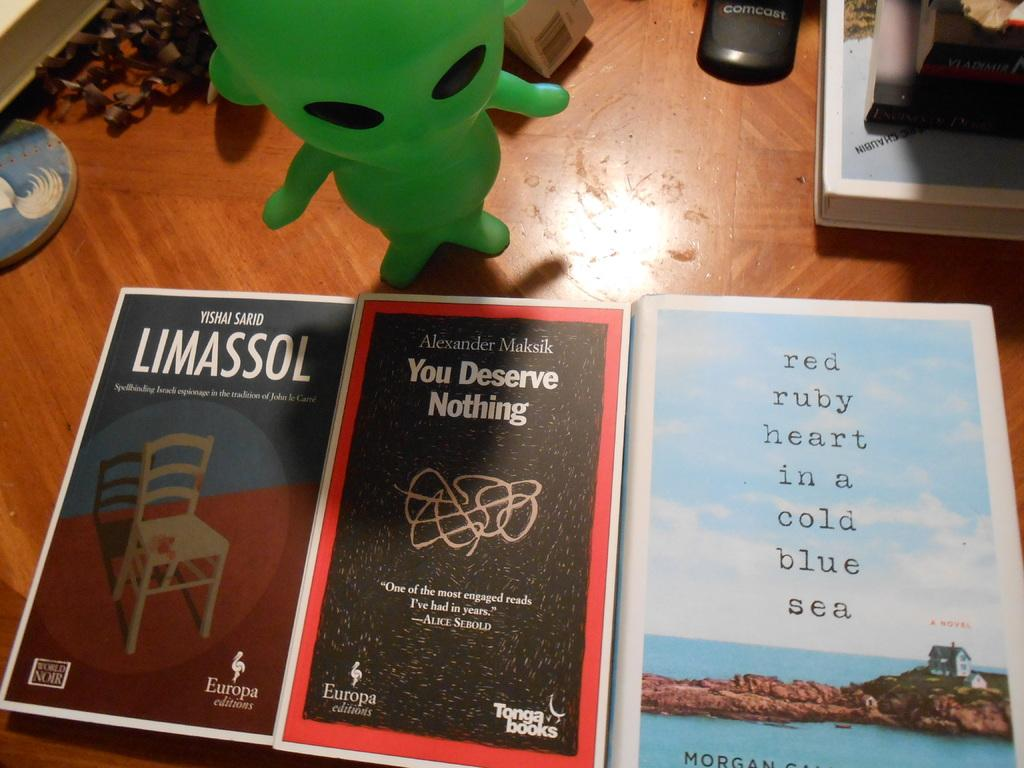<image>
Describe the image concisely. Black and red book titled You Deserve Nothing in between other books. 